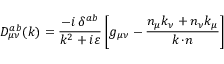Convert formula to latex. <formula><loc_0><loc_0><loc_500><loc_500>D _ { \mu \nu } ^ { a b } ( k ) = \frac { - i \, \delta ^ { a b } } { k ^ { 2 } + i \varepsilon } \left [ g _ { \mu \nu } - \frac { n _ { \mu } k _ { \nu } + n _ { \nu } k _ { \mu } } { k \, \cdot \, n } \right ]</formula> 